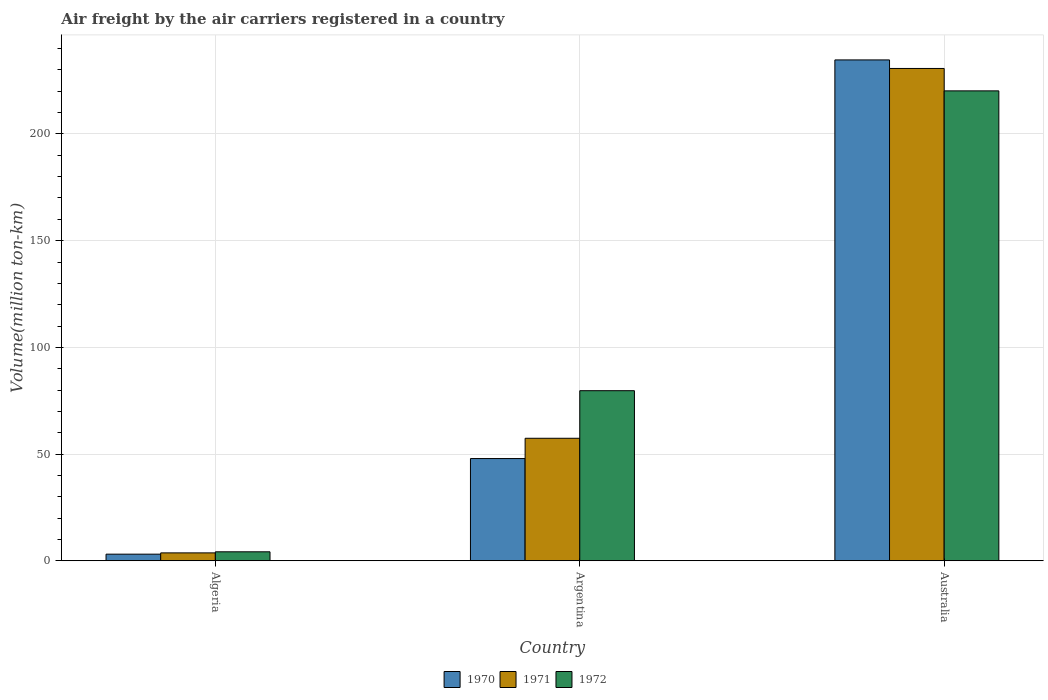How many different coloured bars are there?
Keep it short and to the point. 3. How many groups of bars are there?
Your answer should be very brief. 3. Are the number of bars per tick equal to the number of legend labels?
Ensure brevity in your answer.  Yes. How many bars are there on the 3rd tick from the left?
Offer a terse response. 3. What is the label of the 3rd group of bars from the left?
Ensure brevity in your answer.  Australia. In how many cases, is the number of bars for a given country not equal to the number of legend labels?
Keep it short and to the point. 0. What is the volume of the air carriers in 1972 in Algeria?
Ensure brevity in your answer.  4.2. Across all countries, what is the maximum volume of the air carriers in 1970?
Give a very brief answer. 234.7. Across all countries, what is the minimum volume of the air carriers in 1970?
Your answer should be very brief. 3.1. In which country was the volume of the air carriers in 1972 minimum?
Offer a terse response. Algeria. What is the total volume of the air carriers in 1970 in the graph?
Your answer should be very brief. 285.7. What is the difference between the volume of the air carriers in 1971 in Algeria and that in Australia?
Keep it short and to the point. -227. What is the difference between the volume of the air carriers in 1971 in Algeria and the volume of the air carriers in 1970 in Australia?
Give a very brief answer. -231. What is the average volume of the air carriers in 1972 per country?
Keep it short and to the point. 101.37. What is the difference between the volume of the air carriers of/in 1971 and volume of the air carriers of/in 1970 in Algeria?
Your answer should be compact. 0.6. In how many countries, is the volume of the air carriers in 1972 greater than 50 million ton-km?
Offer a terse response. 2. What is the ratio of the volume of the air carriers in 1971 in Argentina to that in Australia?
Offer a very short reply. 0.25. Is the difference between the volume of the air carriers in 1971 in Algeria and Australia greater than the difference between the volume of the air carriers in 1970 in Algeria and Australia?
Offer a very short reply. Yes. What is the difference between the highest and the second highest volume of the air carriers in 1972?
Ensure brevity in your answer.  216. What is the difference between the highest and the lowest volume of the air carriers in 1971?
Your answer should be compact. 227. Is the sum of the volume of the air carriers in 1972 in Argentina and Australia greater than the maximum volume of the air carriers in 1971 across all countries?
Your answer should be compact. Yes. What does the 1st bar from the left in Argentina represents?
Keep it short and to the point. 1970. Is it the case that in every country, the sum of the volume of the air carriers in 1972 and volume of the air carriers in 1971 is greater than the volume of the air carriers in 1970?
Ensure brevity in your answer.  Yes. Are the values on the major ticks of Y-axis written in scientific E-notation?
Provide a short and direct response. No. Does the graph contain any zero values?
Provide a succinct answer. No. Where does the legend appear in the graph?
Your answer should be compact. Bottom center. How many legend labels are there?
Your answer should be compact. 3. How are the legend labels stacked?
Your answer should be very brief. Horizontal. What is the title of the graph?
Keep it short and to the point. Air freight by the air carriers registered in a country. What is the label or title of the X-axis?
Make the answer very short. Country. What is the label or title of the Y-axis?
Your response must be concise. Volume(million ton-km). What is the Volume(million ton-km) of 1970 in Algeria?
Make the answer very short. 3.1. What is the Volume(million ton-km) of 1971 in Algeria?
Make the answer very short. 3.7. What is the Volume(million ton-km) in 1972 in Algeria?
Make the answer very short. 4.2. What is the Volume(million ton-km) in 1970 in Argentina?
Your response must be concise. 47.9. What is the Volume(million ton-km) of 1971 in Argentina?
Provide a succinct answer. 57.4. What is the Volume(million ton-km) of 1972 in Argentina?
Your response must be concise. 79.7. What is the Volume(million ton-km) of 1970 in Australia?
Ensure brevity in your answer.  234.7. What is the Volume(million ton-km) in 1971 in Australia?
Your answer should be very brief. 230.7. What is the Volume(million ton-km) of 1972 in Australia?
Provide a short and direct response. 220.2. Across all countries, what is the maximum Volume(million ton-km) of 1970?
Make the answer very short. 234.7. Across all countries, what is the maximum Volume(million ton-km) of 1971?
Provide a short and direct response. 230.7. Across all countries, what is the maximum Volume(million ton-km) of 1972?
Make the answer very short. 220.2. Across all countries, what is the minimum Volume(million ton-km) of 1970?
Provide a short and direct response. 3.1. Across all countries, what is the minimum Volume(million ton-km) of 1971?
Offer a very short reply. 3.7. Across all countries, what is the minimum Volume(million ton-km) of 1972?
Your answer should be very brief. 4.2. What is the total Volume(million ton-km) of 1970 in the graph?
Provide a succinct answer. 285.7. What is the total Volume(million ton-km) in 1971 in the graph?
Give a very brief answer. 291.8. What is the total Volume(million ton-km) of 1972 in the graph?
Offer a terse response. 304.1. What is the difference between the Volume(million ton-km) of 1970 in Algeria and that in Argentina?
Offer a terse response. -44.8. What is the difference between the Volume(million ton-km) in 1971 in Algeria and that in Argentina?
Provide a short and direct response. -53.7. What is the difference between the Volume(million ton-km) of 1972 in Algeria and that in Argentina?
Offer a very short reply. -75.5. What is the difference between the Volume(million ton-km) in 1970 in Algeria and that in Australia?
Your answer should be very brief. -231.6. What is the difference between the Volume(million ton-km) of 1971 in Algeria and that in Australia?
Make the answer very short. -227. What is the difference between the Volume(million ton-km) in 1972 in Algeria and that in Australia?
Offer a very short reply. -216. What is the difference between the Volume(million ton-km) in 1970 in Argentina and that in Australia?
Offer a very short reply. -186.8. What is the difference between the Volume(million ton-km) of 1971 in Argentina and that in Australia?
Give a very brief answer. -173.3. What is the difference between the Volume(million ton-km) of 1972 in Argentina and that in Australia?
Make the answer very short. -140.5. What is the difference between the Volume(million ton-km) of 1970 in Algeria and the Volume(million ton-km) of 1971 in Argentina?
Provide a succinct answer. -54.3. What is the difference between the Volume(million ton-km) in 1970 in Algeria and the Volume(million ton-km) in 1972 in Argentina?
Ensure brevity in your answer.  -76.6. What is the difference between the Volume(million ton-km) of 1971 in Algeria and the Volume(million ton-km) of 1972 in Argentina?
Keep it short and to the point. -76. What is the difference between the Volume(million ton-km) of 1970 in Algeria and the Volume(million ton-km) of 1971 in Australia?
Give a very brief answer. -227.6. What is the difference between the Volume(million ton-km) in 1970 in Algeria and the Volume(million ton-km) in 1972 in Australia?
Offer a very short reply. -217.1. What is the difference between the Volume(million ton-km) in 1971 in Algeria and the Volume(million ton-km) in 1972 in Australia?
Give a very brief answer. -216.5. What is the difference between the Volume(million ton-km) of 1970 in Argentina and the Volume(million ton-km) of 1971 in Australia?
Your answer should be compact. -182.8. What is the difference between the Volume(million ton-km) of 1970 in Argentina and the Volume(million ton-km) of 1972 in Australia?
Provide a short and direct response. -172.3. What is the difference between the Volume(million ton-km) of 1971 in Argentina and the Volume(million ton-km) of 1972 in Australia?
Offer a very short reply. -162.8. What is the average Volume(million ton-km) of 1970 per country?
Offer a terse response. 95.23. What is the average Volume(million ton-km) in 1971 per country?
Your response must be concise. 97.27. What is the average Volume(million ton-km) of 1972 per country?
Offer a terse response. 101.37. What is the difference between the Volume(million ton-km) of 1970 and Volume(million ton-km) of 1971 in Algeria?
Offer a very short reply. -0.6. What is the difference between the Volume(million ton-km) in 1970 and Volume(million ton-km) in 1971 in Argentina?
Make the answer very short. -9.5. What is the difference between the Volume(million ton-km) of 1970 and Volume(million ton-km) of 1972 in Argentina?
Your answer should be very brief. -31.8. What is the difference between the Volume(million ton-km) of 1971 and Volume(million ton-km) of 1972 in Argentina?
Provide a succinct answer. -22.3. What is the difference between the Volume(million ton-km) in 1970 and Volume(million ton-km) in 1971 in Australia?
Ensure brevity in your answer.  4. What is the difference between the Volume(million ton-km) of 1970 and Volume(million ton-km) of 1972 in Australia?
Your answer should be compact. 14.5. What is the difference between the Volume(million ton-km) in 1971 and Volume(million ton-km) in 1972 in Australia?
Keep it short and to the point. 10.5. What is the ratio of the Volume(million ton-km) in 1970 in Algeria to that in Argentina?
Keep it short and to the point. 0.06. What is the ratio of the Volume(million ton-km) in 1971 in Algeria to that in Argentina?
Offer a terse response. 0.06. What is the ratio of the Volume(million ton-km) of 1972 in Algeria to that in Argentina?
Make the answer very short. 0.05. What is the ratio of the Volume(million ton-km) of 1970 in Algeria to that in Australia?
Provide a succinct answer. 0.01. What is the ratio of the Volume(million ton-km) of 1971 in Algeria to that in Australia?
Provide a short and direct response. 0.02. What is the ratio of the Volume(million ton-km) of 1972 in Algeria to that in Australia?
Give a very brief answer. 0.02. What is the ratio of the Volume(million ton-km) in 1970 in Argentina to that in Australia?
Offer a terse response. 0.2. What is the ratio of the Volume(million ton-km) in 1971 in Argentina to that in Australia?
Make the answer very short. 0.25. What is the ratio of the Volume(million ton-km) in 1972 in Argentina to that in Australia?
Ensure brevity in your answer.  0.36. What is the difference between the highest and the second highest Volume(million ton-km) of 1970?
Offer a terse response. 186.8. What is the difference between the highest and the second highest Volume(million ton-km) in 1971?
Make the answer very short. 173.3. What is the difference between the highest and the second highest Volume(million ton-km) of 1972?
Ensure brevity in your answer.  140.5. What is the difference between the highest and the lowest Volume(million ton-km) in 1970?
Offer a terse response. 231.6. What is the difference between the highest and the lowest Volume(million ton-km) of 1971?
Your answer should be compact. 227. What is the difference between the highest and the lowest Volume(million ton-km) of 1972?
Offer a very short reply. 216. 